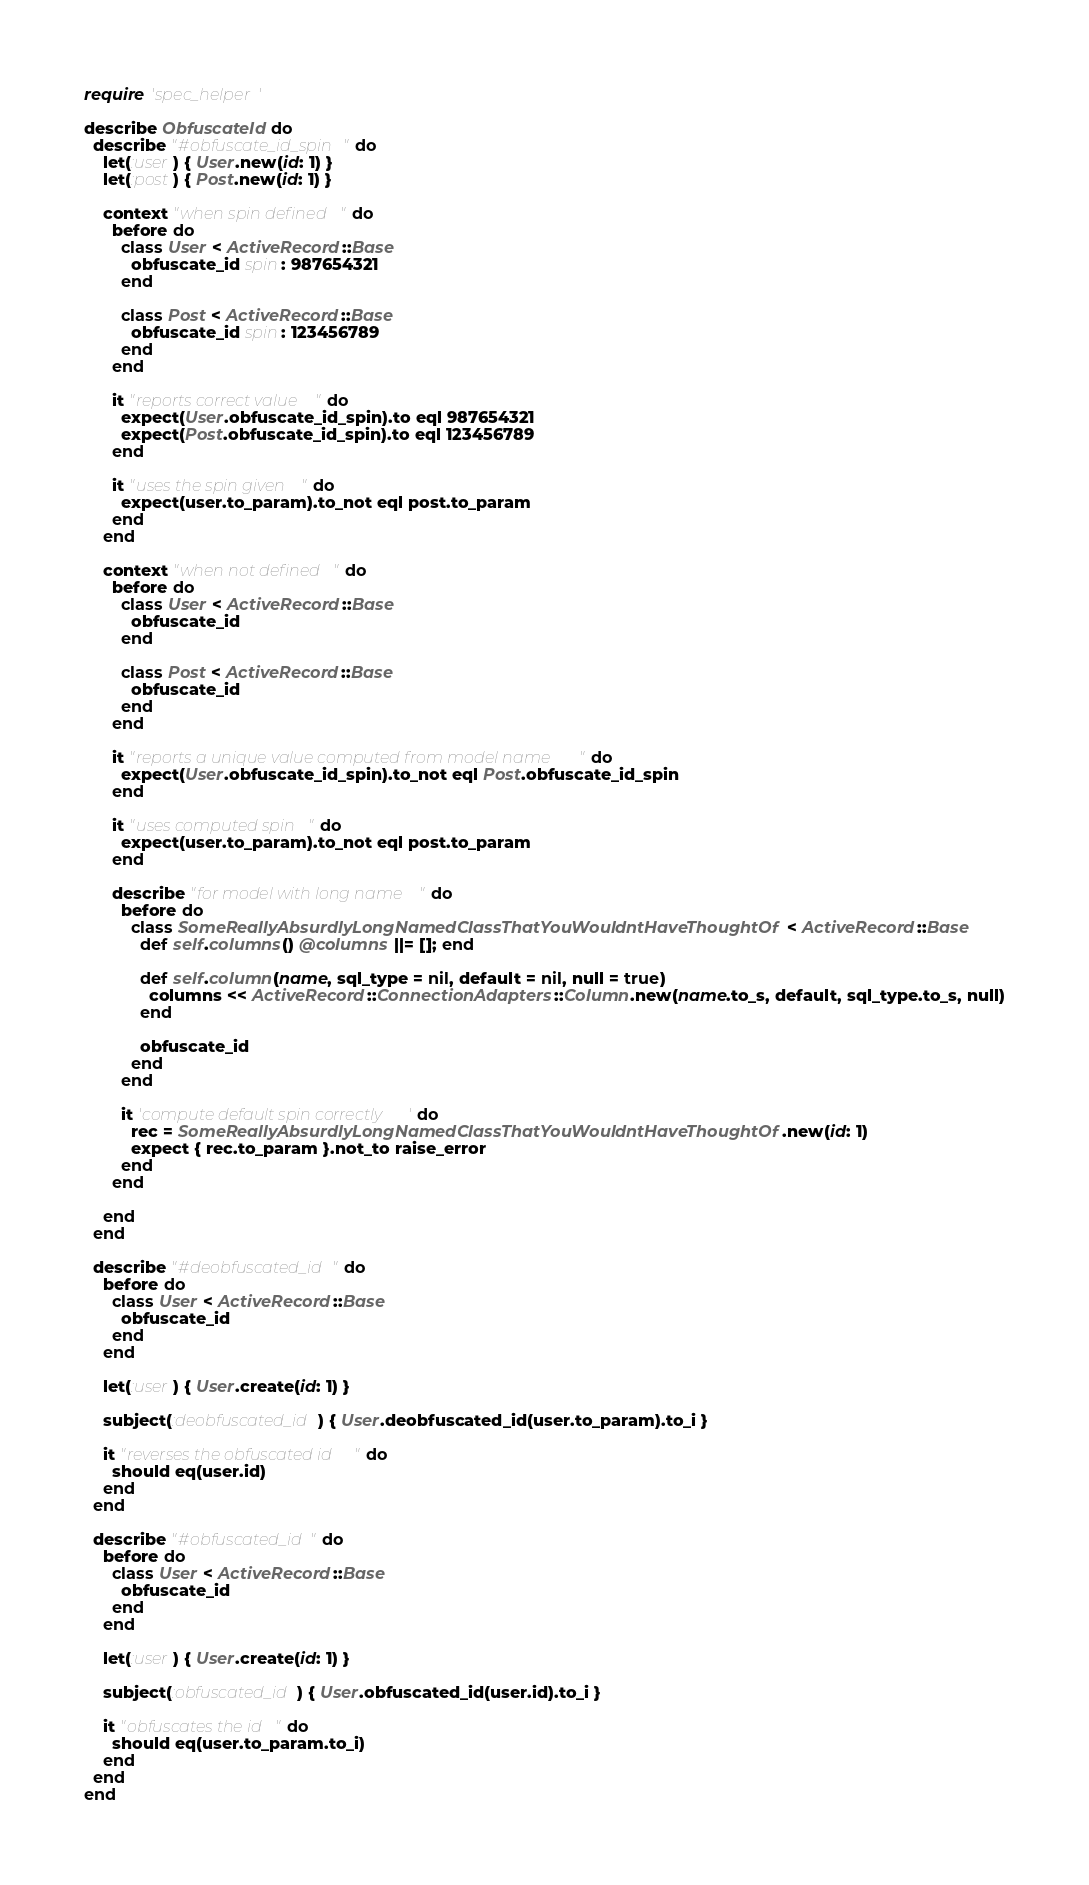<code> <loc_0><loc_0><loc_500><loc_500><_Ruby_>require 'spec_helper'

describe ObfuscateId do
  describe "#obfuscate_id_spin" do
    let(:user) { User.new(id: 1) }
    let(:post) { Post.new(id: 1) }

    context "when spin defined" do
      before do
        class User < ActiveRecord::Base
          obfuscate_id spin: 987654321
        end

        class Post < ActiveRecord::Base
          obfuscate_id spin: 123456789
        end
      end

      it "reports correct value" do
        expect(User.obfuscate_id_spin).to eql 987654321
        expect(Post.obfuscate_id_spin).to eql 123456789
      end

      it "uses the spin given" do
        expect(user.to_param).to_not eql post.to_param
      end
    end

    context "when not defined" do
      before do
        class User < ActiveRecord::Base
          obfuscate_id
        end

        class Post < ActiveRecord::Base
          obfuscate_id
        end
      end

      it "reports a unique value computed from model name" do
        expect(User.obfuscate_id_spin).to_not eql Post.obfuscate_id_spin
      end

      it "uses computed spin" do
        expect(user.to_param).to_not eql post.to_param
      end

      describe "for model with long name" do
        before do
          class SomeReallyAbsurdlyLongNamedClassThatYouWouldntHaveThoughtOf < ActiveRecord::Base
            def self.columns() @columns ||= []; end

            def self.column(name, sql_type = nil, default = nil, null = true)
              columns << ActiveRecord::ConnectionAdapters::Column.new(name.to_s, default, sql_type.to_s, null)
            end

            obfuscate_id
          end
        end

        it 'compute default spin correctly' do
          rec = SomeReallyAbsurdlyLongNamedClassThatYouWouldntHaveThoughtOf.new(id: 1)
          expect { rec.to_param }.not_to raise_error
        end
      end

    end
  end

  describe "#deobfuscated_id" do
    before do
      class User < ActiveRecord::Base
        obfuscate_id
      end
    end

    let(:user) { User.create(id: 1) }

    subject(:deobfuscated_id) { User.deobfuscated_id(user.to_param).to_i }

    it "reverses the obfuscated id" do
      should eq(user.id)
    end
  end

  describe "#obfuscated_id" do
    before do
      class User < ActiveRecord::Base
        obfuscate_id
      end
    end

    let(:user) { User.create(id: 1) }

    subject(:obfuscated_id) { User.obfuscated_id(user.id).to_i }

    it "obfuscates the id" do
      should eq(user.to_param.to_i)
    end
  end
end
</code> 